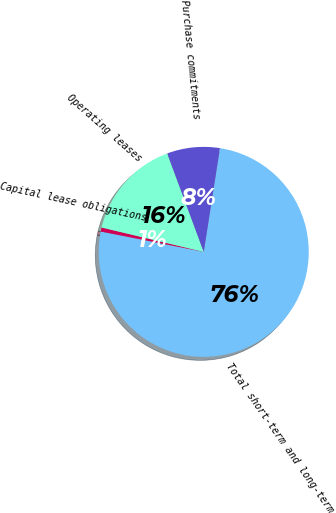Convert chart. <chart><loc_0><loc_0><loc_500><loc_500><pie_chart><fcel>Total short-term and long-term<fcel>Capital lease obligations<fcel>Operating leases<fcel>Purchase commitments<nl><fcel>75.64%<fcel>0.62%<fcel>15.62%<fcel>8.12%<nl></chart> 